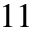Convert formula to latex. <formula><loc_0><loc_0><loc_500><loc_500>1 1</formula> 